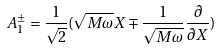Convert formula to latex. <formula><loc_0><loc_0><loc_500><loc_500>A _ { 1 } ^ { \pm } = \frac { 1 } { \sqrt { 2 } } ( \sqrt { M \omega } X \mp \frac { 1 } { \sqrt { M \omega } } \frac { \partial } { \partial X } )</formula> 